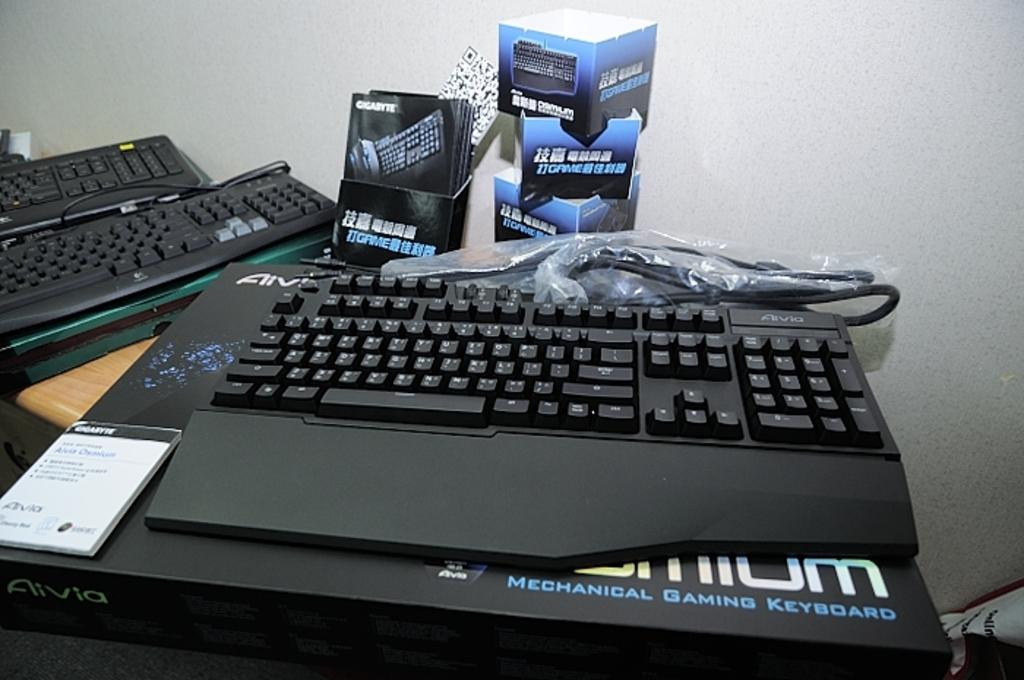<image>
Write a terse but informative summary of the picture. The black keyboard is a mechanical gaming keyboard 